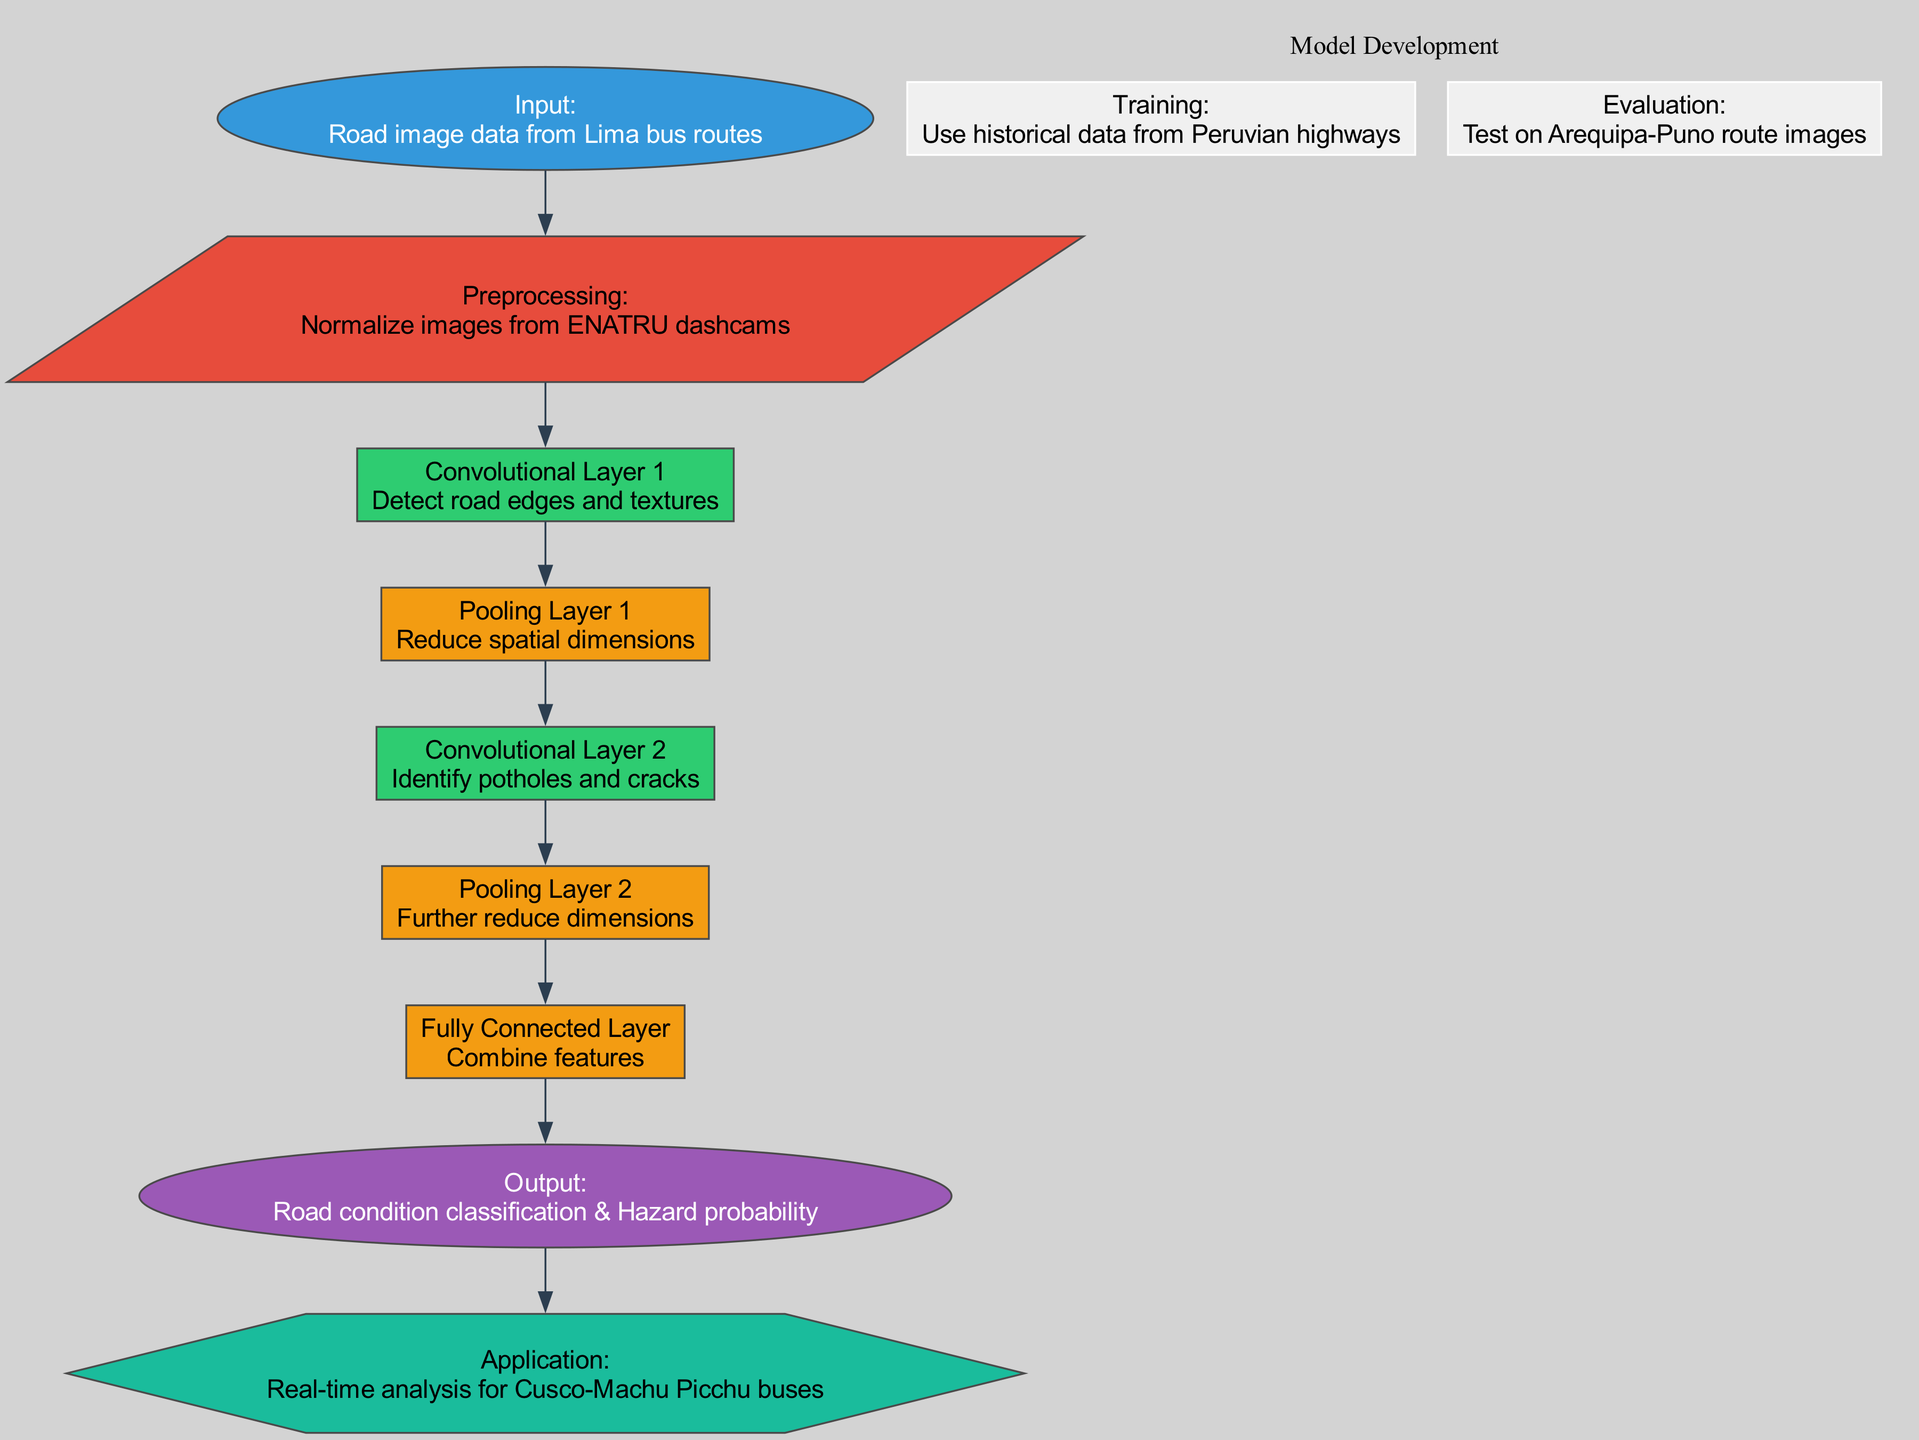What is the input for the CNN? The input node specifies that the CNN uses "Road image data from Lima bus routes" as its input data for analysis.
Answer: Road image data from Lima bus routes How many layers are in the CNN? By counting the specified layers listed in the diagram, there are a total of five layers: two convolutional layers, two pooling layers, and one fully connected layer.
Answer: Five layers What is the purpose of Pooling Layer 1? Pooling Layer 1's function is indicated in the diagram as "Reduce spatial dimensions," which is a standard function to decrease the size of the output from the previous convolutional layer.
Answer: Reduce spatial dimensions What output is generated by the CNN? The output node indicates that the CNN generates two outputs: "Road condition classification" and "Hazard probability."
Answer: Road condition classification & Hazard probability Which layer identifies potholes and cracks? The diagram specifies that "Convolutional Layer 2" is responsible for identifying potholes and cracks, as described in its function.
Answer: Convolutional Layer 2 What is the purpose of the fully connected layer? The purpose of the fully connected layer is to "Combine features," which means it takes the outputs from the previous layers and combines them to enable the final output classification.
Answer: Combine features What data is used for training the CNN? The diagram clearly states that the CNN is trained using "historical data from Peruvian highways," which provides the basis for the learning process.
Answer: Historical data from Peruvian highways On which route is the CNN evaluated? According to the diagram, the evaluation of the model is conducted on "Arequipa-Puno route images," indicating where the model's effectiveness is tested.
Answer: Arequipa-Puno route images What application is mentioned for the CNN? The application node reveals that the CNN is designed for "Real-time analysis for Cusco-Machu Picchu buses," indicating its practical use case.
Answer: Real-time analysis for Cusco-Machu Picchu buses 